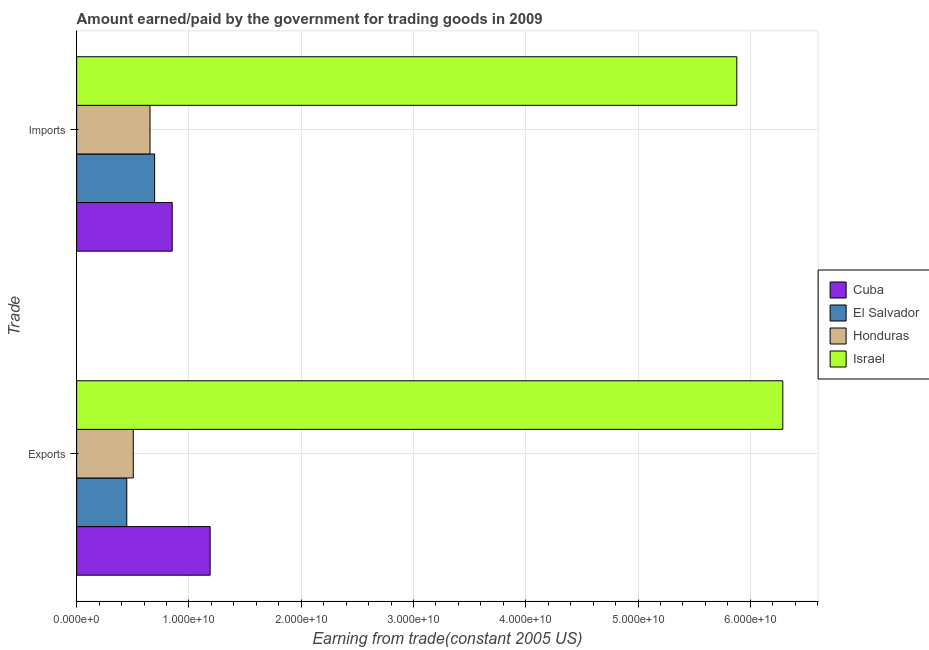Are the number of bars on each tick of the Y-axis equal?
Provide a short and direct response. Yes. What is the label of the 2nd group of bars from the top?
Give a very brief answer. Exports. What is the amount paid for imports in Cuba?
Offer a very short reply. 8.51e+09. Across all countries, what is the maximum amount paid for imports?
Offer a very short reply. 5.88e+1. Across all countries, what is the minimum amount earned from exports?
Your response must be concise. 4.46e+09. In which country was the amount earned from exports maximum?
Your answer should be compact. Israel. In which country was the amount paid for imports minimum?
Your response must be concise. Honduras. What is the total amount earned from exports in the graph?
Your answer should be very brief. 8.43e+1. What is the difference between the amount paid for imports in Honduras and that in El Salvador?
Keep it short and to the point. -4.13e+08. What is the difference between the amount paid for imports in Honduras and the amount earned from exports in El Salvador?
Offer a very short reply. 2.07e+09. What is the average amount earned from exports per country?
Give a very brief answer. 2.11e+1. What is the difference between the amount earned from exports and amount paid for imports in El Salvador?
Your answer should be compact. -2.48e+09. In how many countries, is the amount earned from exports greater than 18000000000 US$?
Make the answer very short. 1. What is the ratio of the amount paid for imports in El Salvador to that in Cuba?
Provide a short and direct response. 0.82. Is the amount earned from exports in Honduras less than that in Cuba?
Offer a very short reply. Yes. In how many countries, is the amount paid for imports greater than the average amount paid for imports taken over all countries?
Give a very brief answer. 1. What does the 4th bar from the top in Exports represents?
Your answer should be compact. Cuba. What does the 4th bar from the bottom in Imports represents?
Provide a short and direct response. Israel. How many countries are there in the graph?
Your answer should be very brief. 4. Does the graph contain any zero values?
Keep it short and to the point. No. Does the graph contain grids?
Ensure brevity in your answer.  Yes. Where does the legend appear in the graph?
Make the answer very short. Center right. How many legend labels are there?
Provide a succinct answer. 4. What is the title of the graph?
Provide a short and direct response. Amount earned/paid by the government for trading goods in 2009. What is the label or title of the X-axis?
Make the answer very short. Earning from trade(constant 2005 US). What is the label or title of the Y-axis?
Offer a very short reply. Trade. What is the Earning from trade(constant 2005 US) in Cuba in Exports?
Offer a very short reply. 1.19e+1. What is the Earning from trade(constant 2005 US) of El Salvador in Exports?
Ensure brevity in your answer.  4.46e+09. What is the Earning from trade(constant 2005 US) of Honduras in Exports?
Your response must be concise. 5.04e+09. What is the Earning from trade(constant 2005 US) of Israel in Exports?
Make the answer very short. 6.29e+1. What is the Earning from trade(constant 2005 US) of Cuba in Imports?
Make the answer very short. 8.51e+09. What is the Earning from trade(constant 2005 US) in El Salvador in Imports?
Make the answer very short. 6.95e+09. What is the Earning from trade(constant 2005 US) of Honduras in Imports?
Your response must be concise. 6.53e+09. What is the Earning from trade(constant 2005 US) in Israel in Imports?
Offer a terse response. 5.88e+1. Across all Trade, what is the maximum Earning from trade(constant 2005 US) in Cuba?
Your response must be concise. 1.19e+1. Across all Trade, what is the maximum Earning from trade(constant 2005 US) of El Salvador?
Provide a succinct answer. 6.95e+09. Across all Trade, what is the maximum Earning from trade(constant 2005 US) in Honduras?
Make the answer very short. 6.53e+09. Across all Trade, what is the maximum Earning from trade(constant 2005 US) of Israel?
Offer a terse response. 6.29e+1. Across all Trade, what is the minimum Earning from trade(constant 2005 US) in Cuba?
Offer a terse response. 8.51e+09. Across all Trade, what is the minimum Earning from trade(constant 2005 US) of El Salvador?
Your answer should be compact. 4.46e+09. Across all Trade, what is the minimum Earning from trade(constant 2005 US) of Honduras?
Make the answer very short. 5.04e+09. Across all Trade, what is the minimum Earning from trade(constant 2005 US) in Israel?
Give a very brief answer. 5.88e+1. What is the total Earning from trade(constant 2005 US) of Cuba in the graph?
Your answer should be compact. 2.04e+1. What is the total Earning from trade(constant 2005 US) in El Salvador in the graph?
Your answer should be very brief. 1.14e+1. What is the total Earning from trade(constant 2005 US) in Honduras in the graph?
Your answer should be very brief. 1.16e+1. What is the total Earning from trade(constant 2005 US) in Israel in the graph?
Provide a succinct answer. 1.22e+11. What is the difference between the Earning from trade(constant 2005 US) in Cuba in Exports and that in Imports?
Offer a very short reply. 3.38e+09. What is the difference between the Earning from trade(constant 2005 US) in El Salvador in Exports and that in Imports?
Keep it short and to the point. -2.48e+09. What is the difference between the Earning from trade(constant 2005 US) of Honduras in Exports and that in Imports?
Offer a terse response. -1.49e+09. What is the difference between the Earning from trade(constant 2005 US) in Israel in Exports and that in Imports?
Offer a very short reply. 4.10e+09. What is the difference between the Earning from trade(constant 2005 US) in Cuba in Exports and the Earning from trade(constant 2005 US) in El Salvador in Imports?
Your answer should be compact. 4.94e+09. What is the difference between the Earning from trade(constant 2005 US) in Cuba in Exports and the Earning from trade(constant 2005 US) in Honduras in Imports?
Give a very brief answer. 5.36e+09. What is the difference between the Earning from trade(constant 2005 US) of Cuba in Exports and the Earning from trade(constant 2005 US) of Israel in Imports?
Provide a short and direct response. -4.69e+1. What is the difference between the Earning from trade(constant 2005 US) of El Salvador in Exports and the Earning from trade(constant 2005 US) of Honduras in Imports?
Give a very brief answer. -2.07e+09. What is the difference between the Earning from trade(constant 2005 US) in El Salvador in Exports and the Earning from trade(constant 2005 US) in Israel in Imports?
Your answer should be compact. -5.43e+1. What is the difference between the Earning from trade(constant 2005 US) in Honduras in Exports and the Earning from trade(constant 2005 US) in Israel in Imports?
Give a very brief answer. -5.38e+1. What is the average Earning from trade(constant 2005 US) of Cuba per Trade?
Your answer should be compact. 1.02e+1. What is the average Earning from trade(constant 2005 US) of El Salvador per Trade?
Provide a succinct answer. 5.70e+09. What is the average Earning from trade(constant 2005 US) of Honduras per Trade?
Ensure brevity in your answer.  5.79e+09. What is the average Earning from trade(constant 2005 US) in Israel per Trade?
Your answer should be very brief. 6.08e+1. What is the difference between the Earning from trade(constant 2005 US) in Cuba and Earning from trade(constant 2005 US) in El Salvador in Exports?
Provide a succinct answer. 7.43e+09. What is the difference between the Earning from trade(constant 2005 US) in Cuba and Earning from trade(constant 2005 US) in Honduras in Exports?
Make the answer very short. 6.85e+09. What is the difference between the Earning from trade(constant 2005 US) in Cuba and Earning from trade(constant 2005 US) in Israel in Exports?
Provide a short and direct response. -5.10e+1. What is the difference between the Earning from trade(constant 2005 US) in El Salvador and Earning from trade(constant 2005 US) in Honduras in Exports?
Provide a succinct answer. -5.78e+08. What is the difference between the Earning from trade(constant 2005 US) in El Salvador and Earning from trade(constant 2005 US) in Israel in Exports?
Offer a very short reply. -5.84e+1. What is the difference between the Earning from trade(constant 2005 US) in Honduras and Earning from trade(constant 2005 US) in Israel in Exports?
Ensure brevity in your answer.  -5.79e+1. What is the difference between the Earning from trade(constant 2005 US) of Cuba and Earning from trade(constant 2005 US) of El Salvador in Imports?
Ensure brevity in your answer.  1.56e+09. What is the difference between the Earning from trade(constant 2005 US) in Cuba and Earning from trade(constant 2005 US) in Honduras in Imports?
Give a very brief answer. 1.98e+09. What is the difference between the Earning from trade(constant 2005 US) of Cuba and Earning from trade(constant 2005 US) of Israel in Imports?
Your response must be concise. -5.03e+1. What is the difference between the Earning from trade(constant 2005 US) of El Salvador and Earning from trade(constant 2005 US) of Honduras in Imports?
Make the answer very short. 4.13e+08. What is the difference between the Earning from trade(constant 2005 US) in El Salvador and Earning from trade(constant 2005 US) in Israel in Imports?
Provide a succinct answer. -5.18e+1. What is the difference between the Earning from trade(constant 2005 US) of Honduras and Earning from trade(constant 2005 US) of Israel in Imports?
Offer a terse response. -5.23e+1. What is the ratio of the Earning from trade(constant 2005 US) of Cuba in Exports to that in Imports?
Your response must be concise. 1.4. What is the ratio of the Earning from trade(constant 2005 US) in El Salvador in Exports to that in Imports?
Your answer should be compact. 0.64. What is the ratio of the Earning from trade(constant 2005 US) in Honduras in Exports to that in Imports?
Give a very brief answer. 0.77. What is the ratio of the Earning from trade(constant 2005 US) in Israel in Exports to that in Imports?
Your response must be concise. 1.07. What is the difference between the highest and the second highest Earning from trade(constant 2005 US) in Cuba?
Keep it short and to the point. 3.38e+09. What is the difference between the highest and the second highest Earning from trade(constant 2005 US) in El Salvador?
Make the answer very short. 2.48e+09. What is the difference between the highest and the second highest Earning from trade(constant 2005 US) of Honduras?
Provide a succinct answer. 1.49e+09. What is the difference between the highest and the second highest Earning from trade(constant 2005 US) in Israel?
Your answer should be very brief. 4.10e+09. What is the difference between the highest and the lowest Earning from trade(constant 2005 US) of Cuba?
Offer a very short reply. 3.38e+09. What is the difference between the highest and the lowest Earning from trade(constant 2005 US) in El Salvador?
Provide a succinct answer. 2.48e+09. What is the difference between the highest and the lowest Earning from trade(constant 2005 US) of Honduras?
Keep it short and to the point. 1.49e+09. What is the difference between the highest and the lowest Earning from trade(constant 2005 US) of Israel?
Your answer should be very brief. 4.10e+09. 